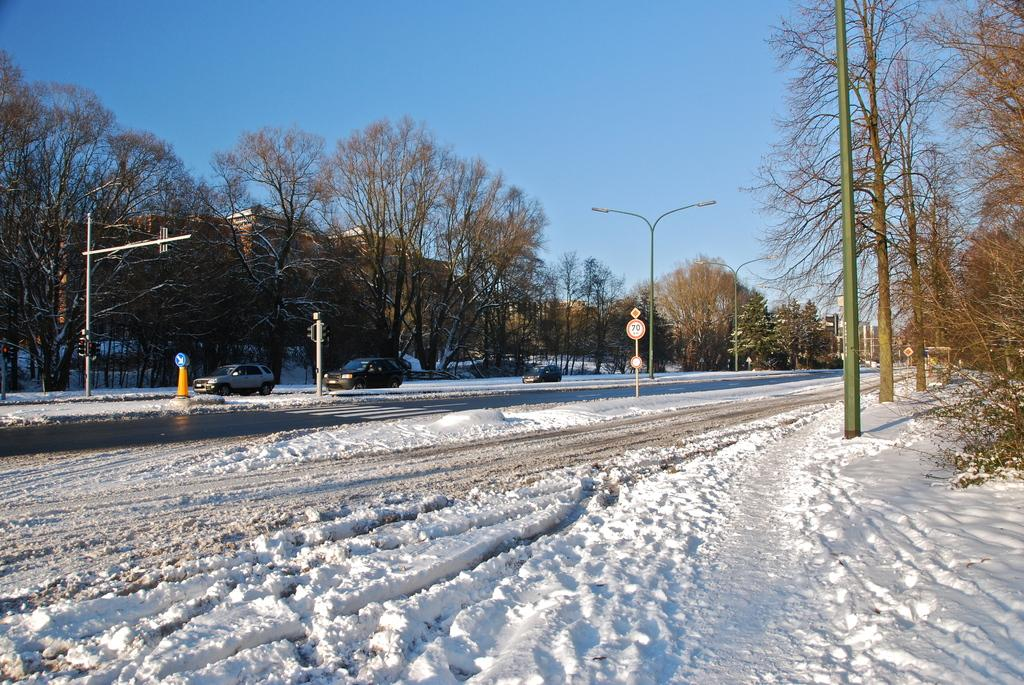What types of objects can be seen in the image? There are vehicles, poles, traffic cones, and trees in the image. What is the condition of the road in the image? The road is covered with snow at the bottom of the image. What is visible at the top of the image? The sky is visible at the top of the image. Can you tell me how many cherries are on the trees in the image? There are no cherries present in the image; it features trees without any visible fruit. What type of shoes are the vehicles wearing in the image? Vehicles do not wear shoes; they are inanimate objects. 